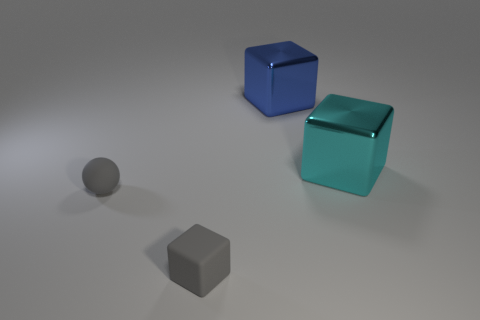There is a big blue object that is right of the small gray rubber thing that is right of the sphere; what is its material?
Your answer should be very brief. Metal. There is a tiny gray rubber object on the left side of the tiny gray rubber thing that is in front of the tiny rubber sphere; is there a cyan object that is right of it?
Keep it short and to the point. Yes. There is a big blue thing that is the same shape as the cyan object; what is its material?
Your answer should be very brief. Metal. Is the blue object made of the same material as the tiny gray ball in front of the large blue thing?
Your answer should be very brief. No. What is the shape of the thing that is to the right of the metallic thing that is behind the cyan shiny cube?
Your response must be concise. Cube. What number of small things are purple metallic cylinders or shiny objects?
Your answer should be compact. 0. What number of blue metallic objects have the same shape as the cyan metallic object?
Your answer should be compact. 1. Do the blue metal thing and the big cyan shiny thing that is to the right of the tiny gray matte cube have the same shape?
Give a very brief answer. Yes. How many gray objects are in front of the sphere?
Offer a very short reply. 1. Are there any gray blocks of the same size as the sphere?
Provide a short and direct response. Yes. 